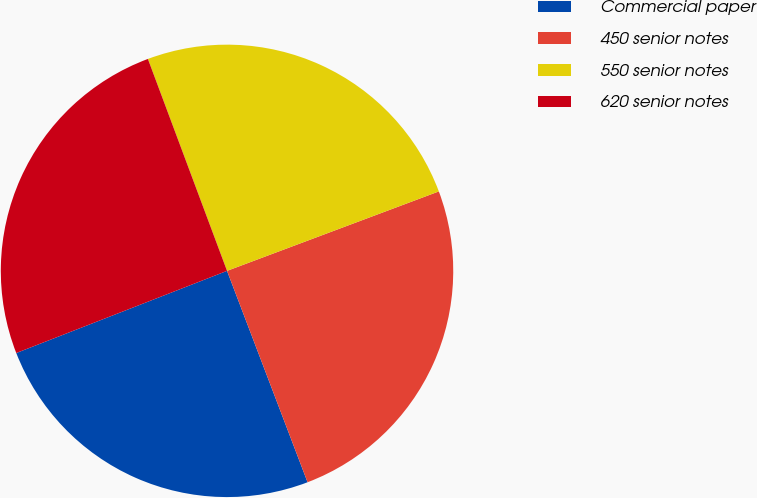Convert chart. <chart><loc_0><loc_0><loc_500><loc_500><pie_chart><fcel>Commercial paper<fcel>450 senior notes<fcel>550 senior notes<fcel>620 senior notes<nl><fcel>24.88%<fcel>24.92%<fcel>24.98%<fcel>25.23%<nl></chart> 